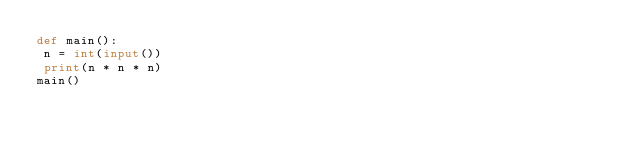Convert code to text. <code><loc_0><loc_0><loc_500><loc_500><_Python_>def main():
 n = int(input())
 print(n * n * n)
main()</code> 